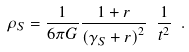<formula> <loc_0><loc_0><loc_500><loc_500>\rho _ { S } = \frac { 1 } { 6 \pi G } \frac { 1 + r } { \left ( \gamma _ { S } + r \right ) ^ { 2 } } \ \frac { 1 } { t ^ { 2 } } \ .</formula> 